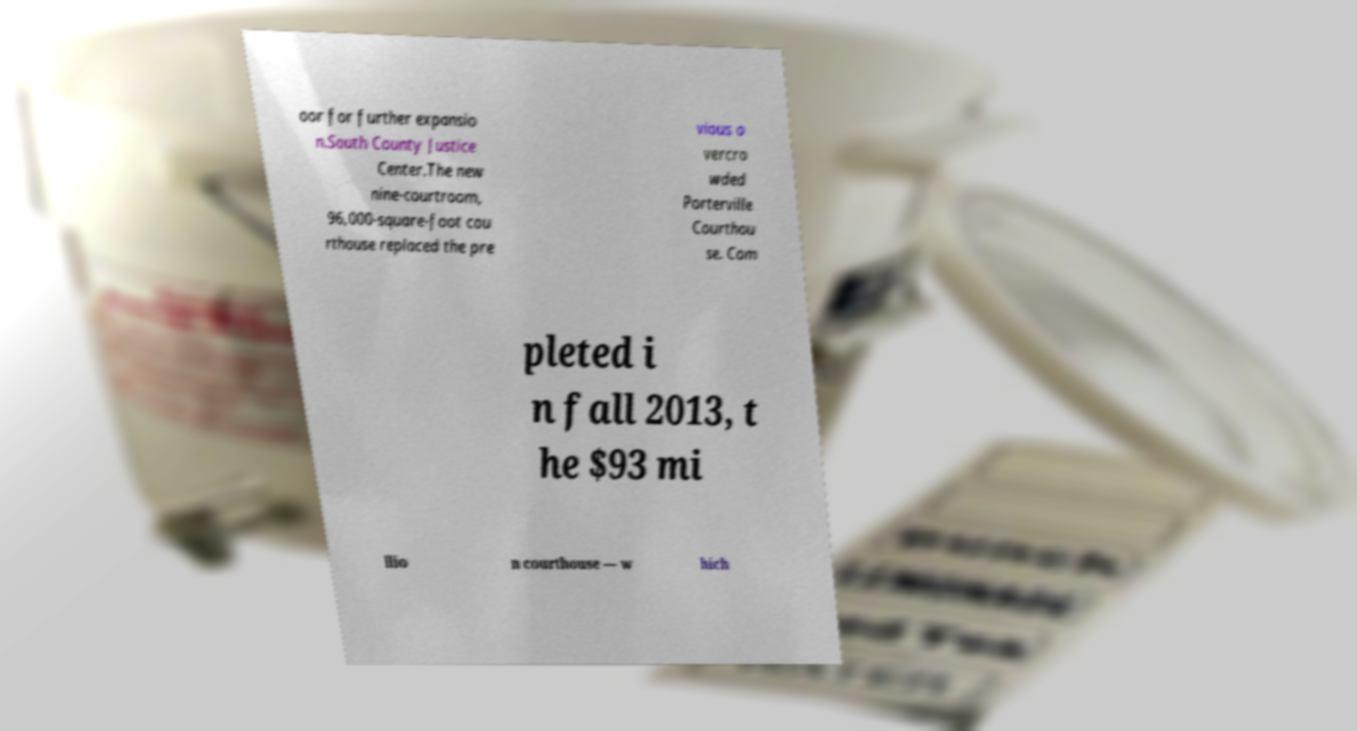There's text embedded in this image that I need extracted. Can you transcribe it verbatim? oor for further expansio n.South County Justice Center.The new nine-courtroom, 96,000-square-foot cou rthouse replaced the pre vious o vercro wded Porterville Courthou se. Com pleted i n fall 2013, t he $93 mi llio n courthouse — w hich 